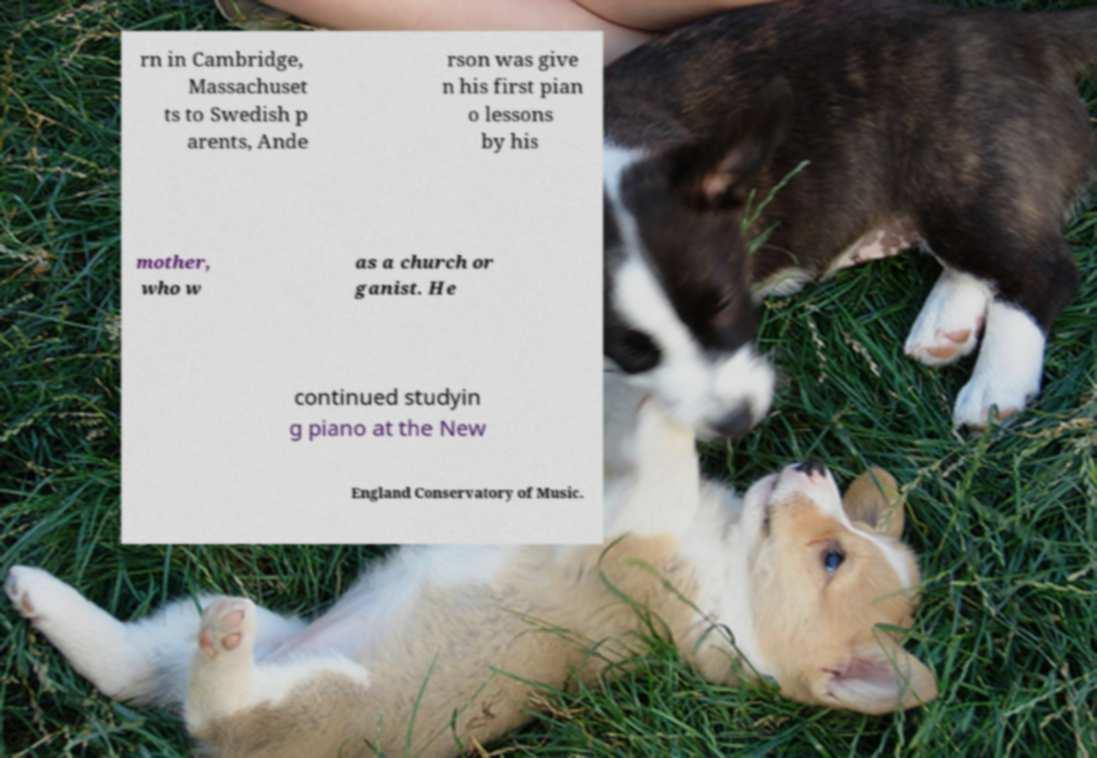Please identify and transcribe the text found in this image. rn in Cambridge, Massachuset ts to Swedish p arents, Ande rson was give n his first pian o lessons by his mother, who w as a church or ganist. He continued studyin g piano at the New England Conservatory of Music. 